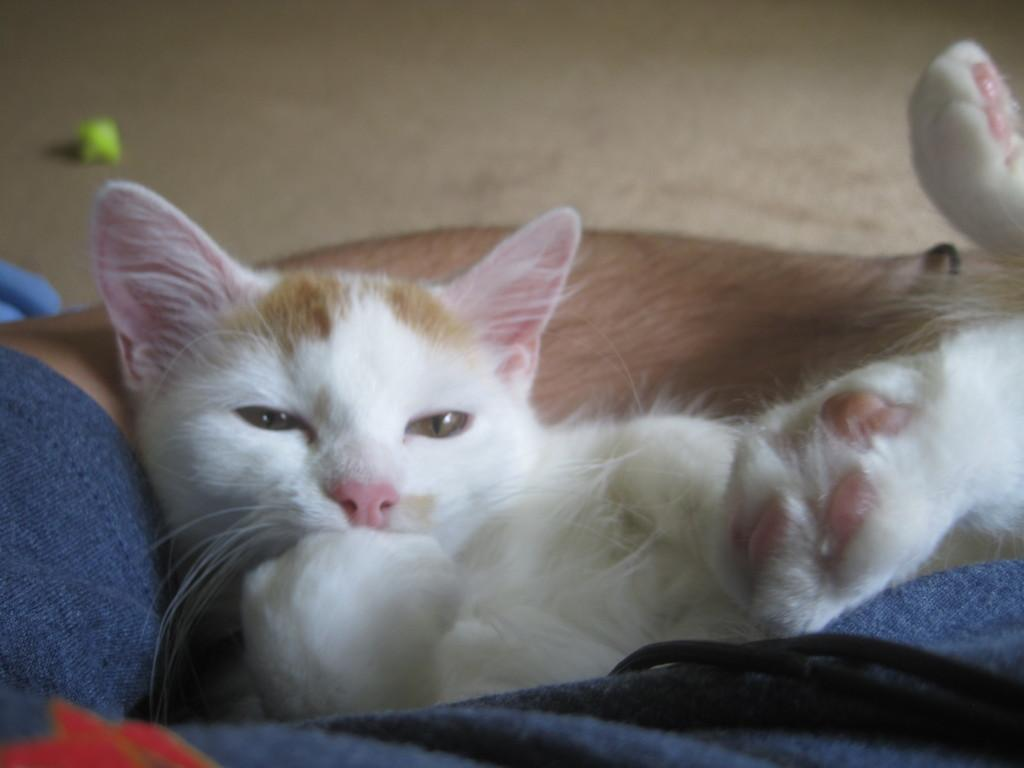What type of animal is in the foreground of the image? There is a white color cat in the foreground of the image. Where is the cat positioned in relation to the person in the image? The cat is between the legs of a person. Can you describe the background of the image? The background of the image is not clear. What type of knife can be seen in the image? There is no knife present in the image. Is there a lake visible in the background of the image? There is no lake visible in the background of the image. 